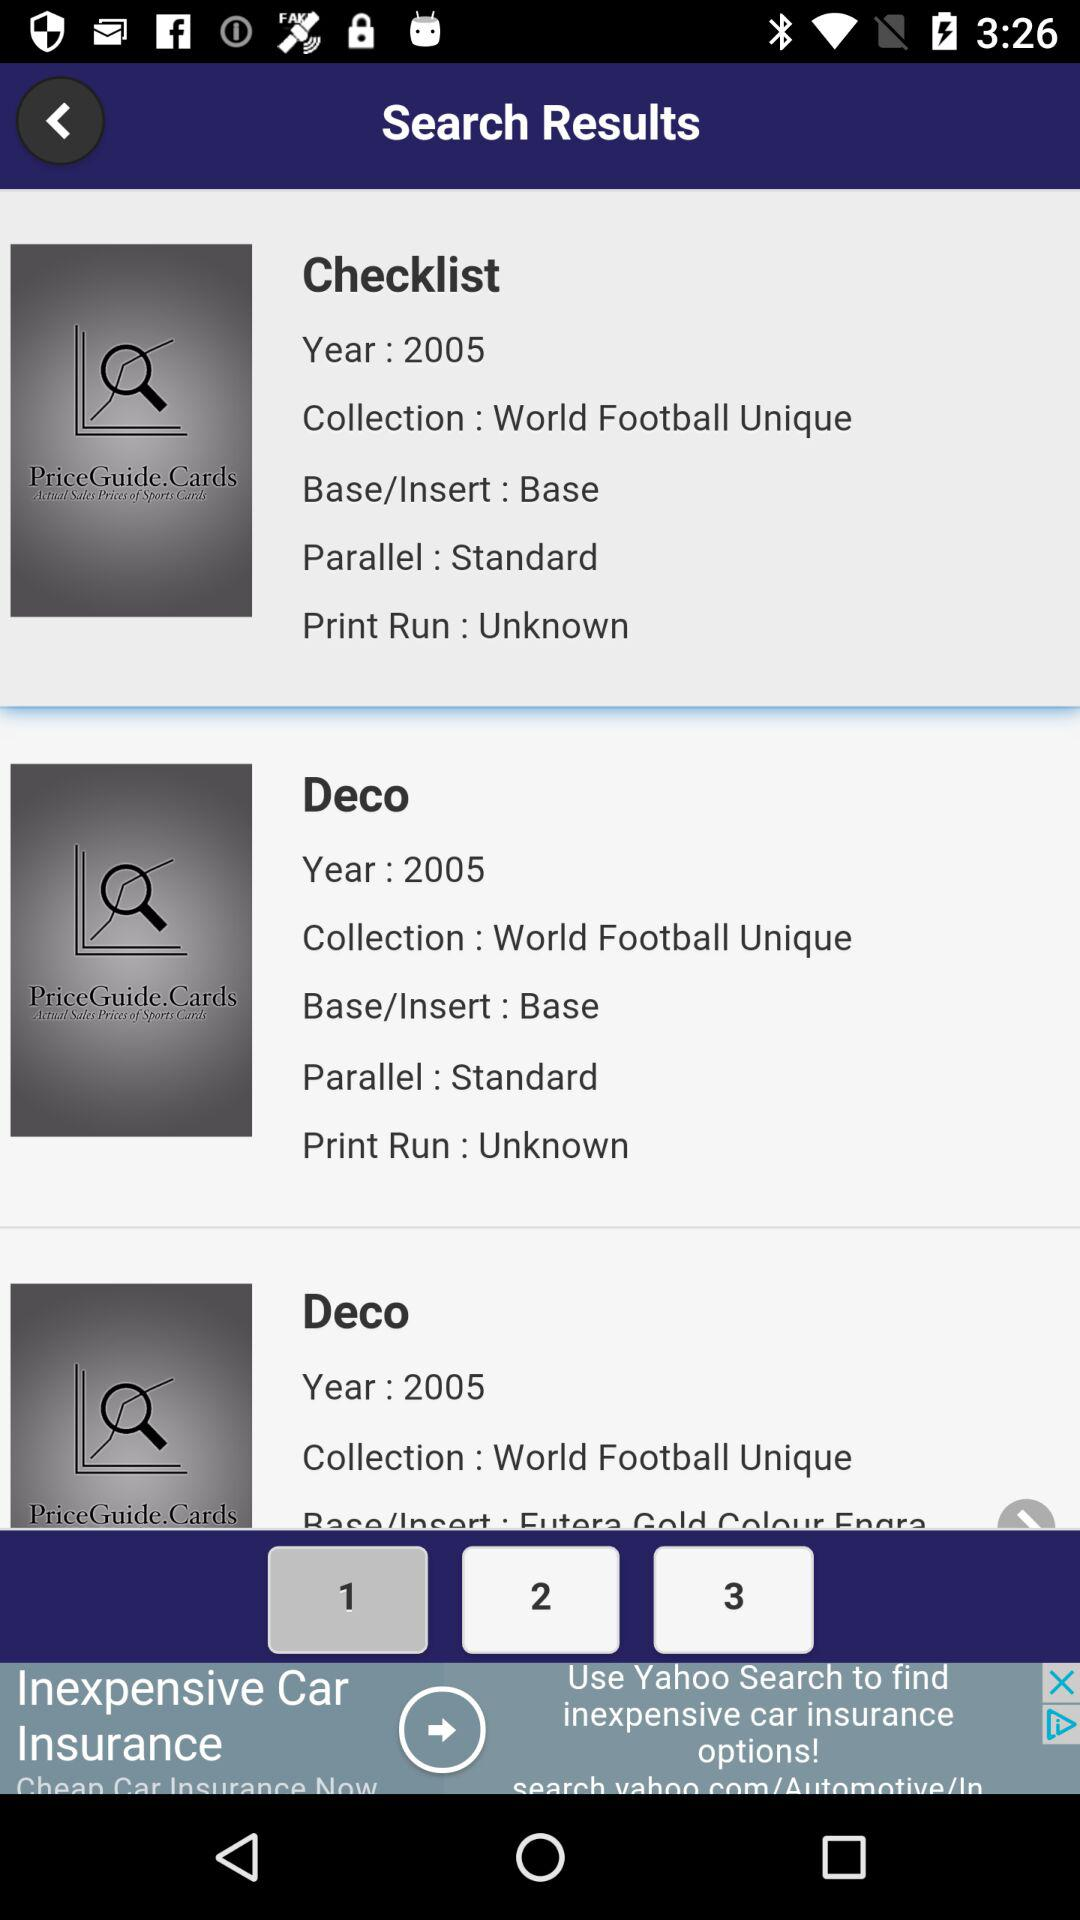What is the status of the parallel of Deco? The status is standard. 